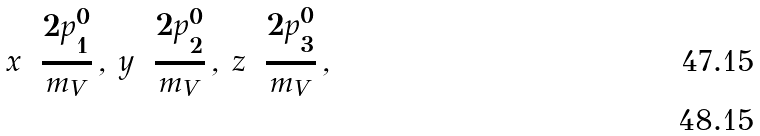Convert formula to latex. <formula><loc_0><loc_0><loc_500><loc_500>x = \frac { 2 p ^ { 0 } _ { 1 } } { m _ { V } } \, , \, y = \frac { 2 p ^ { 0 } _ { 2 } } { m _ { V } } \, , \, z = \frac { 2 p ^ { 0 } _ { 3 } } { m _ { V } } \, , \\</formula> 